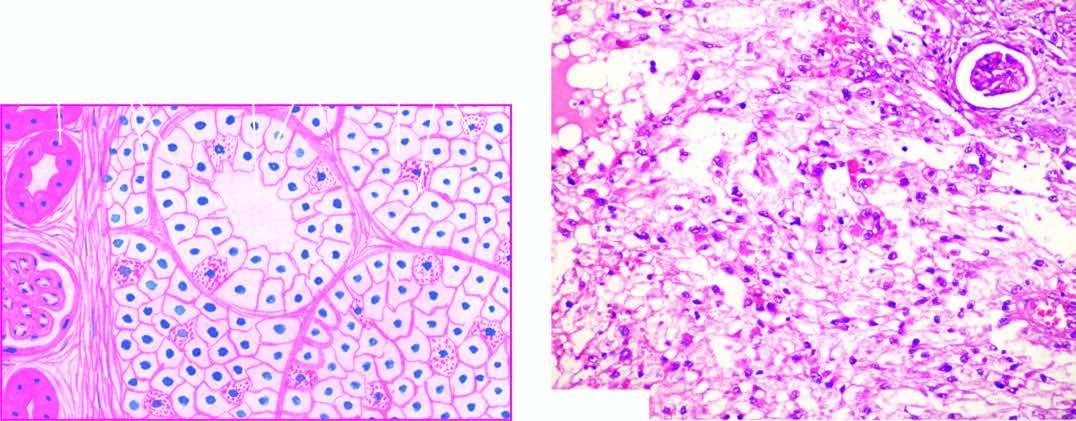do clear cells predominate in the tumour while the stroma is composed of fine and delicate fibrous tissue?
Answer the question using a single word or phrase. Yes 